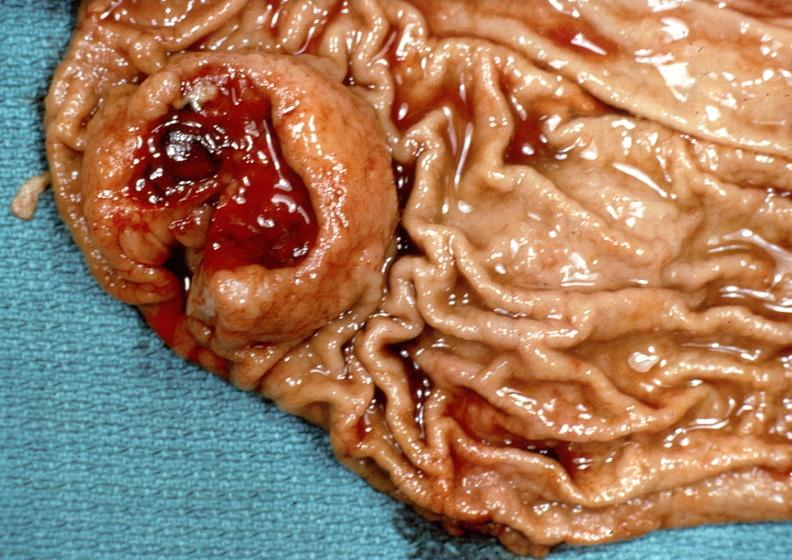does natural color show stomach?
Answer the question using a single word or phrase. No 